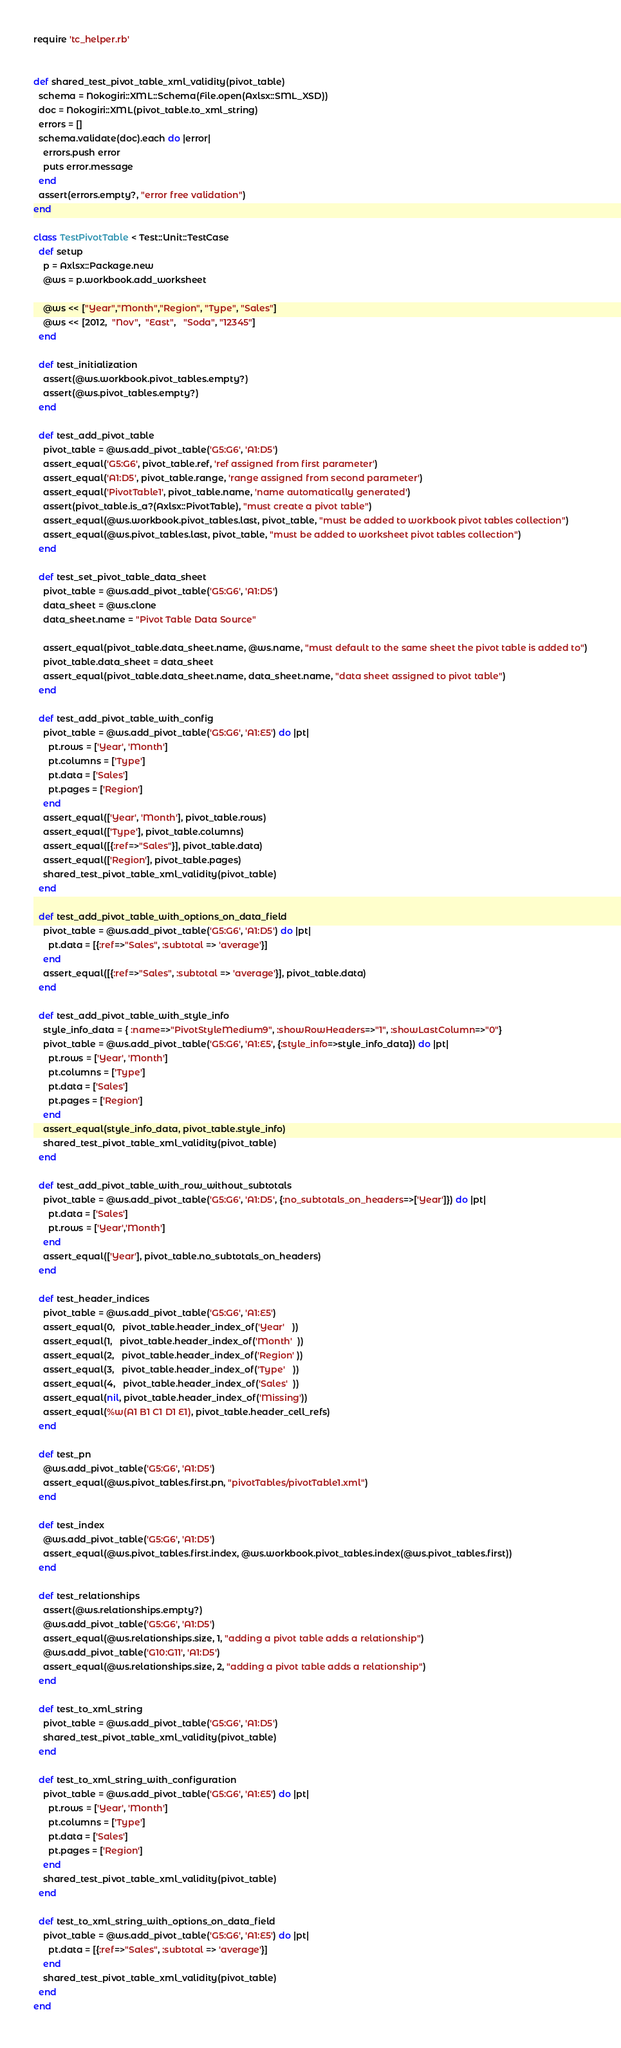<code> <loc_0><loc_0><loc_500><loc_500><_Ruby_>require 'tc_helper.rb'


def shared_test_pivot_table_xml_validity(pivot_table)
  schema = Nokogiri::XML::Schema(File.open(Axlsx::SML_XSD))
  doc = Nokogiri::XML(pivot_table.to_xml_string)
  errors = []
  schema.validate(doc).each do |error|
    errors.push error
    puts error.message
  end
  assert(errors.empty?, "error free validation")
end

class TestPivotTable < Test::Unit::TestCase
  def setup
    p = Axlsx::Package.new
    @ws = p.workbook.add_worksheet

    @ws << ["Year","Month","Region", "Type", "Sales"]
    @ws << [2012,  "Nov",  "East",   "Soda", "12345"]
  end

  def test_initialization
    assert(@ws.workbook.pivot_tables.empty?)
    assert(@ws.pivot_tables.empty?)
  end

  def test_add_pivot_table
    pivot_table = @ws.add_pivot_table('G5:G6', 'A1:D5')
    assert_equal('G5:G6', pivot_table.ref, 'ref assigned from first parameter')
    assert_equal('A1:D5', pivot_table.range, 'range assigned from second parameter')
    assert_equal('PivotTable1', pivot_table.name, 'name automatically generated')
    assert(pivot_table.is_a?(Axlsx::PivotTable), "must create a pivot table")
    assert_equal(@ws.workbook.pivot_tables.last, pivot_table, "must be added to workbook pivot tables collection")
    assert_equal(@ws.pivot_tables.last, pivot_table, "must be added to worksheet pivot tables collection")
  end

  def test_set_pivot_table_data_sheet
    pivot_table = @ws.add_pivot_table('G5:G6', 'A1:D5')
    data_sheet = @ws.clone
    data_sheet.name = "Pivot Table Data Source"

    assert_equal(pivot_table.data_sheet.name, @ws.name, "must default to the same sheet the pivot table is added to")
    pivot_table.data_sheet = data_sheet
    assert_equal(pivot_table.data_sheet.name, data_sheet.name, "data sheet assigned to pivot table")
  end

  def test_add_pivot_table_with_config
    pivot_table = @ws.add_pivot_table('G5:G6', 'A1:E5') do |pt|
      pt.rows = ['Year', 'Month']
      pt.columns = ['Type']
      pt.data = ['Sales']
      pt.pages = ['Region']
    end
    assert_equal(['Year', 'Month'], pivot_table.rows)
    assert_equal(['Type'], pivot_table.columns)
    assert_equal([{:ref=>"Sales"}], pivot_table.data)
    assert_equal(['Region'], pivot_table.pages)
    shared_test_pivot_table_xml_validity(pivot_table)
  end

  def test_add_pivot_table_with_options_on_data_field
    pivot_table = @ws.add_pivot_table('G5:G6', 'A1:D5') do |pt|
      pt.data = [{:ref=>"Sales", :subtotal => 'average'}]
    end
    assert_equal([{:ref=>"Sales", :subtotal => 'average'}], pivot_table.data)
  end

  def test_add_pivot_table_with_style_info
    style_info_data = { :name=>"PivotStyleMedium9", :showRowHeaders=>"1", :showLastColumn=>"0"}
    pivot_table = @ws.add_pivot_table('G5:G6', 'A1:E5', {:style_info=>style_info_data}) do |pt|
      pt.rows = ['Year', 'Month']
      pt.columns = ['Type']
      pt.data = ['Sales']
      pt.pages = ['Region']
    end
    assert_equal(style_info_data, pivot_table.style_info)
    shared_test_pivot_table_xml_validity(pivot_table)
  end

  def test_add_pivot_table_with_row_without_subtotals
    pivot_table = @ws.add_pivot_table('G5:G6', 'A1:D5', {:no_subtotals_on_headers=>['Year']}) do |pt|
      pt.data = ['Sales']
      pt.rows = ['Year','Month']
    end
    assert_equal(['Year'], pivot_table.no_subtotals_on_headers)
  end

  def test_header_indices
    pivot_table = @ws.add_pivot_table('G5:G6', 'A1:E5')
    assert_equal(0,   pivot_table.header_index_of('Year'   ))
    assert_equal(1,   pivot_table.header_index_of('Month'  ))
    assert_equal(2,   pivot_table.header_index_of('Region' ))
    assert_equal(3,   pivot_table.header_index_of('Type'   ))
    assert_equal(4,   pivot_table.header_index_of('Sales'  ))
    assert_equal(nil, pivot_table.header_index_of('Missing'))
    assert_equal(%w(A1 B1 C1 D1 E1), pivot_table.header_cell_refs)
  end

  def test_pn
    @ws.add_pivot_table('G5:G6', 'A1:D5')
    assert_equal(@ws.pivot_tables.first.pn, "pivotTables/pivotTable1.xml")
  end

  def test_index
    @ws.add_pivot_table('G5:G6', 'A1:D5')
    assert_equal(@ws.pivot_tables.first.index, @ws.workbook.pivot_tables.index(@ws.pivot_tables.first))
  end

  def test_relationships
    assert(@ws.relationships.empty?)
    @ws.add_pivot_table('G5:G6', 'A1:D5')
    assert_equal(@ws.relationships.size, 1, "adding a pivot table adds a relationship")
    @ws.add_pivot_table('G10:G11', 'A1:D5')
    assert_equal(@ws.relationships.size, 2, "adding a pivot table adds a relationship")
  end

  def test_to_xml_string
    pivot_table = @ws.add_pivot_table('G5:G6', 'A1:D5')
    shared_test_pivot_table_xml_validity(pivot_table)
  end

  def test_to_xml_string_with_configuration
    pivot_table = @ws.add_pivot_table('G5:G6', 'A1:E5') do |pt|
      pt.rows = ['Year', 'Month']
      pt.columns = ['Type']
      pt.data = ['Sales']
      pt.pages = ['Region']
    end
    shared_test_pivot_table_xml_validity(pivot_table)
  end

  def test_to_xml_string_with_options_on_data_field
    pivot_table = @ws.add_pivot_table('G5:G6', 'A1:E5') do |pt|
      pt.data = [{:ref=>"Sales", :subtotal => 'average'}]
    end
    shared_test_pivot_table_xml_validity(pivot_table)
  end
end
</code> 